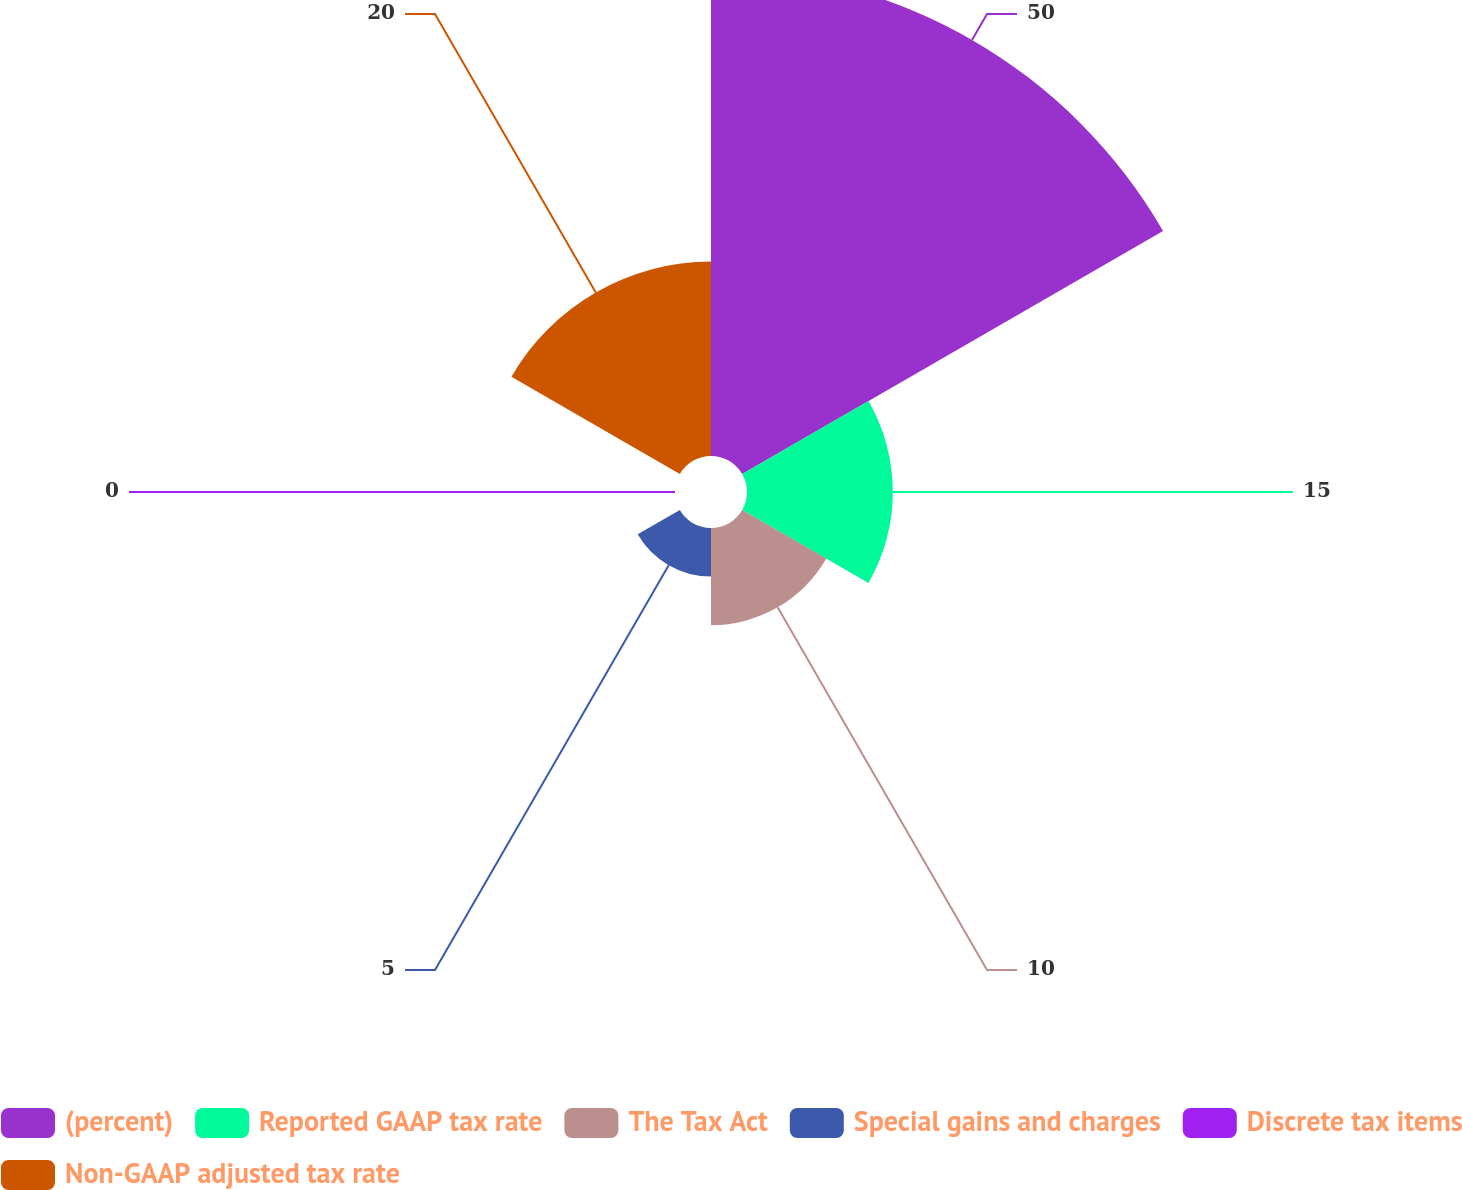Convert chart to OTSL. <chart><loc_0><loc_0><loc_500><loc_500><pie_chart><fcel>(percent)<fcel>Reported GAAP tax rate<fcel>The Tax Act<fcel>Special gains and charges<fcel>Discrete tax items<fcel>Non-GAAP adjusted tax rate<nl><fcel>49.99%<fcel>15.0%<fcel>10.0%<fcel>5.0%<fcel>0.0%<fcel>20.0%<nl></chart> 